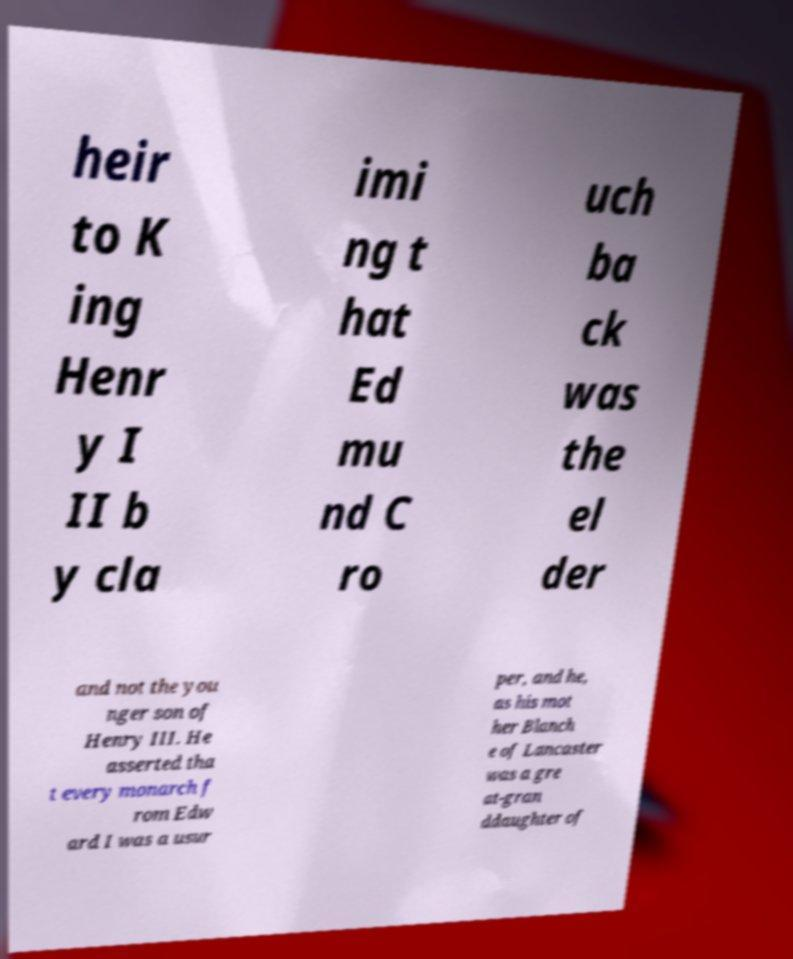What messages or text are displayed in this image? I need them in a readable, typed format. heir to K ing Henr y I II b y cla imi ng t hat Ed mu nd C ro uch ba ck was the el der and not the you nger son of Henry III. He asserted tha t every monarch f rom Edw ard I was a usur per, and he, as his mot her Blanch e of Lancaster was a gre at-gran ddaughter of 